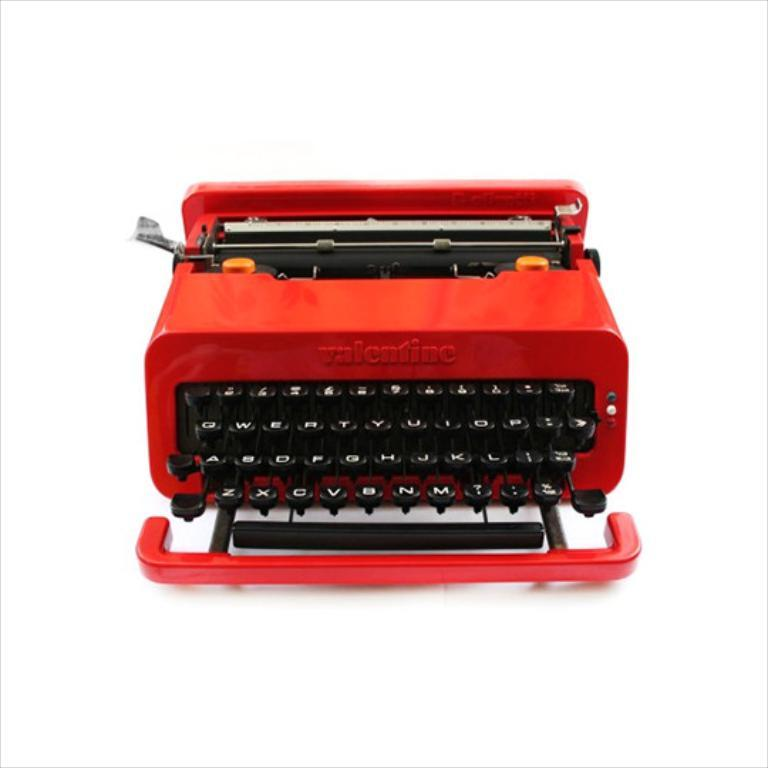<image>
Offer a succinct explanation of the picture presented. An antique bright red Valentino brand manual typewriter. 